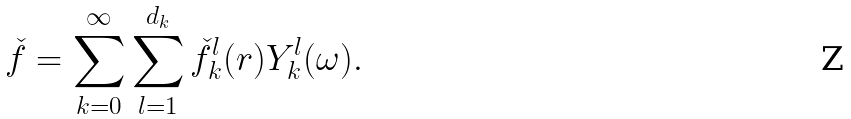Convert formula to latex. <formula><loc_0><loc_0><loc_500><loc_500>\check { f } = \sum _ { k = 0 } ^ { \infty } \sum _ { l = 1 } ^ { d _ { k } } \check { f } ^ { l } _ { k } ( r ) Y ^ { l } _ { k } ( \omega ) .</formula> 